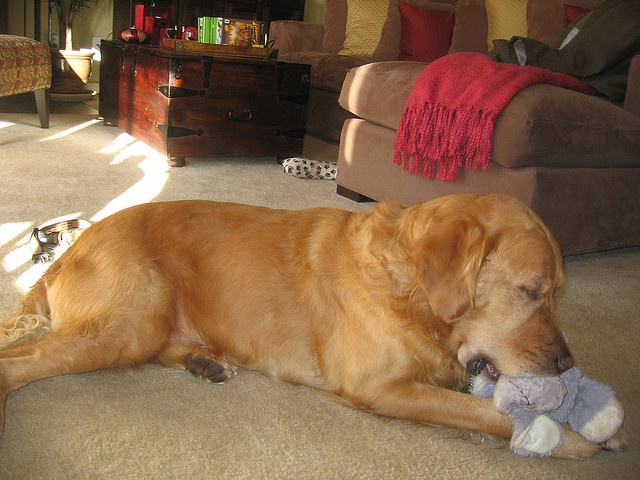Describe the objects in this image and their specific colors. I can see dog in black, brown, and tan tones, couch in black, gray, and brown tones, teddy bear in black, darkgray, and gray tones, couch in black, maroon, and gray tones, and couch in black, maroon, and olive tones in this image. 